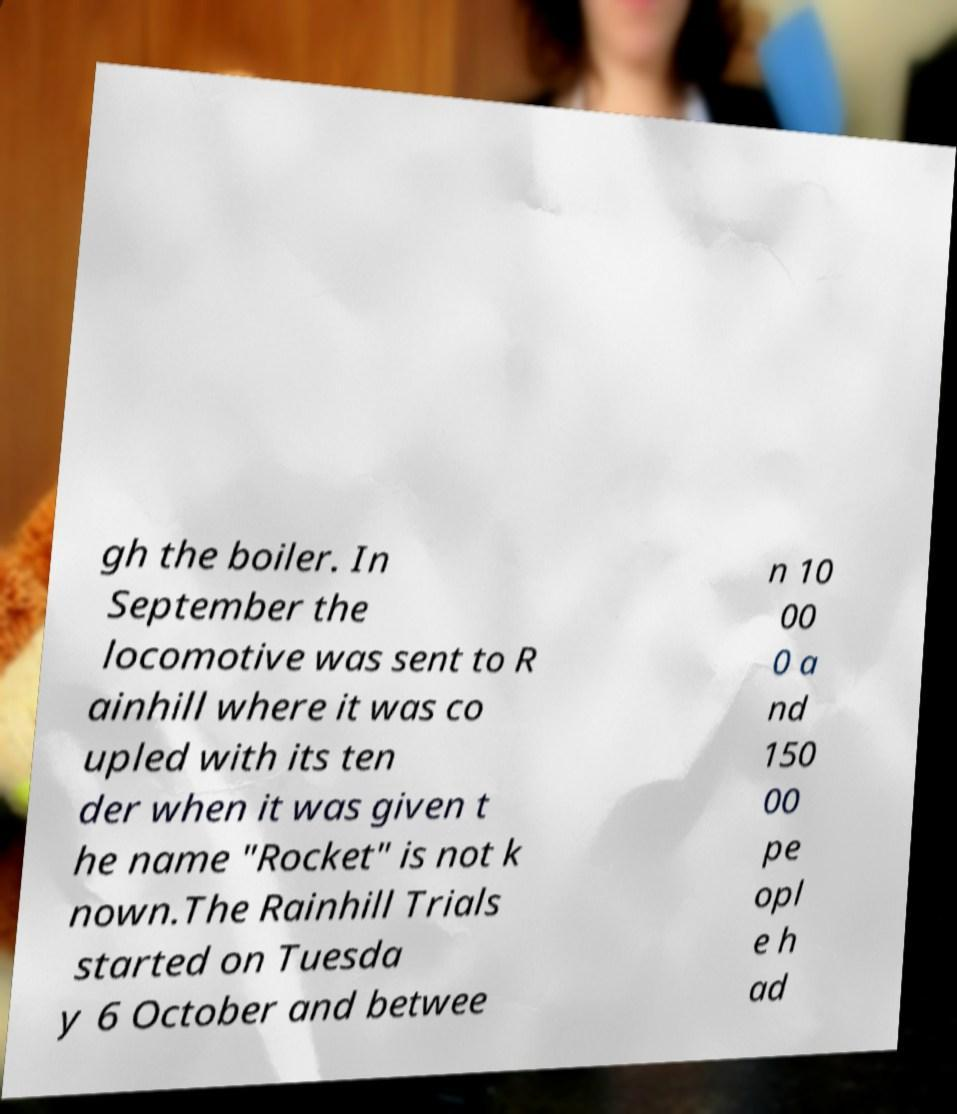Could you extract and type out the text from this image? gh the boiler. In September the locomotive was sent to R ainhill where it was co upled with its ten der when it was given t he name "Rocket" is not k nown.The Rainhill Trials started on Tuesda y 6 October and betwee n 10 00 0 a nd 150 00 pe opl e h ad 